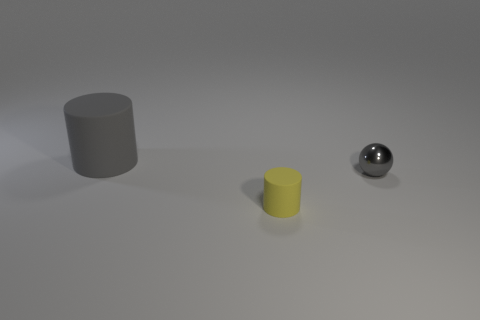What color is the thing to the right of the matte thing that is right of the matte thing behind the gray ball? The object to the right of the matte cylinder, which is to the right of the other matte cylinder behind the gray ball, appears to be a small, matte yellow cylinder. 